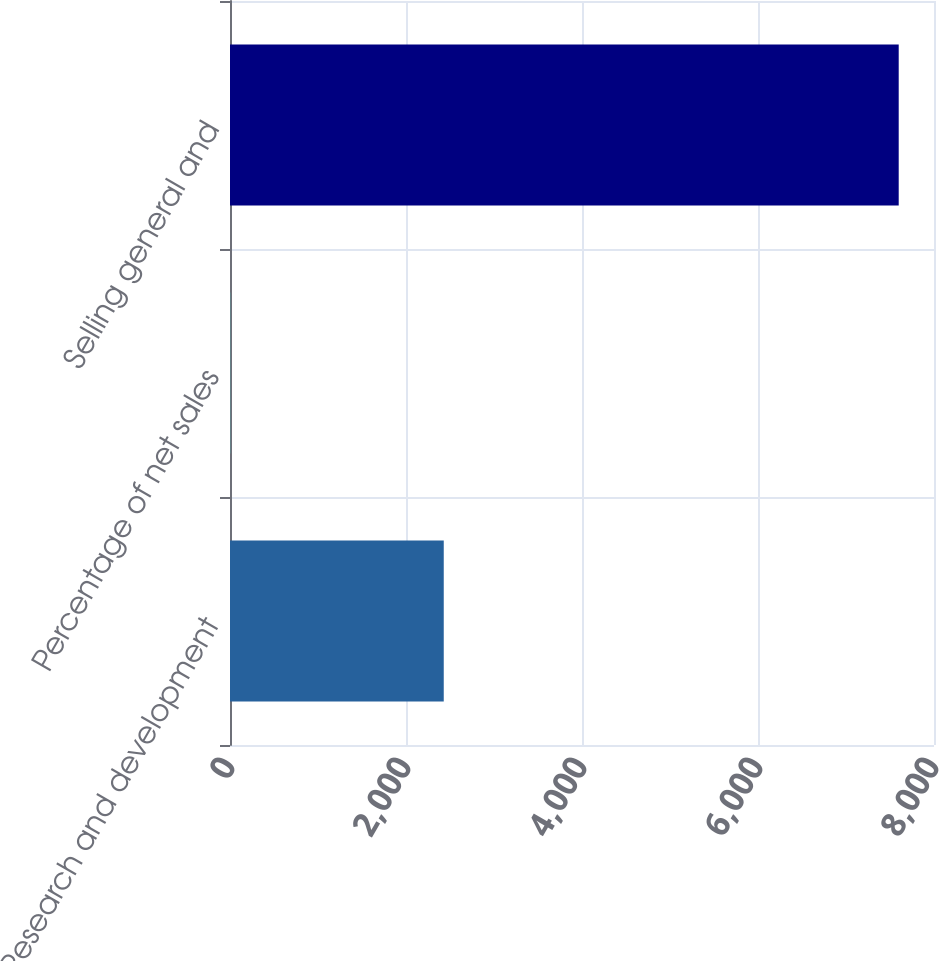<chart> <loc_0><loc_0><loc_500><loc_500><bar_chart><fcel>Research and development<fcel>Percentage of net sales<fcel>Selling general and<nl><fcel>2429<fcel>2<fcel>7599<nl></chart> 